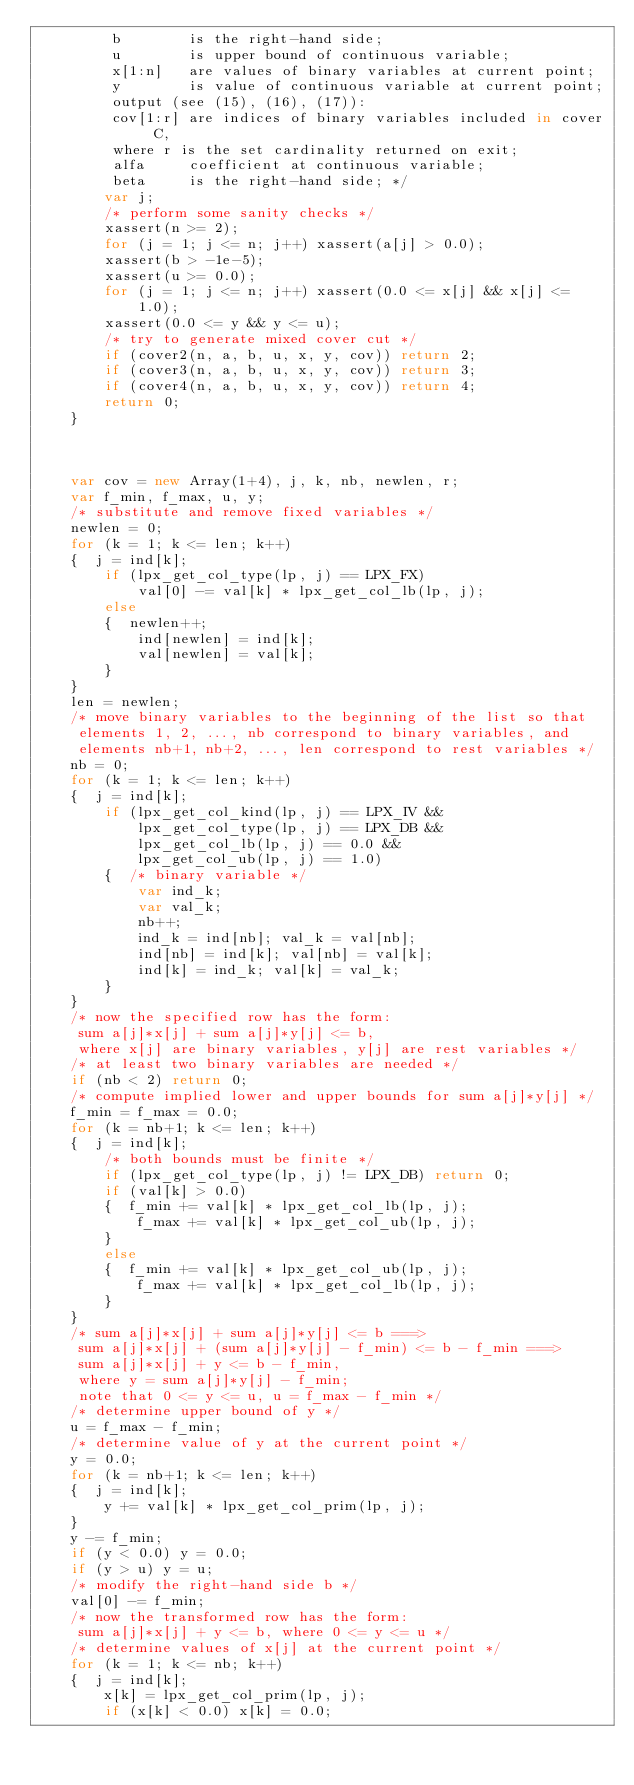Convert code to text. <code><loc_0><loc_0><loc_500><loc_500><_JavaScript_>         b        is the right-hand side;
         u        is upper bound of continuous variable;
         x[1:n]   are values of binary variables at current point;
         y        is value of continuous variable at current point;
         output (see (15), (16), (17)):
         cov[1:r] are indices of binary variables included in cover C,
         where r is the set cardinality returned on exit;
         alfa     coefficient at continuous variable;
         beta     is the right-hand side; */
        var j;
        /* perform some sanity checks */
        xassert(n >= 2);
        for (j = 1; j <= n; j++) xassert(a[j] > 0.0);
        xassert(b > -1e-5);
        xassert(u >= 0.0);
        for (j = 1; j <= n; j++) xassert(0.0 <= x[j] && x[j] <= 1.0);
        xassert(0.0 <= y && y <= u);
        /* try to generate mixed cover cut */
        if (cover2(n, a, b, u, x, y, cov)) return 2;
        if (cover3(n, a, b, u, x, y, cov)) return 3;
        if (cover4(n, a, b, u, x, y, cov)) return 4;
        return 0;
    }



    var cov = new Array(1+4), j, k, nb, newlen, r;
    var f_min, f_max, u, y;
    /* substitute and remove fixed variables */
    newlen = 0;
    for (k = 1; k <= len; k++)
    {  j = ind[k];
        if (lpx_get_col_type(lp, j) == LPX_FX)
            val[0] -= val[k] * lpx_get_col_lb(lp, j);
        else
        {  newlen++;
            ind[newlen] = ind[k];
            val[newlen] = val[k];
        }
    }
    len = newlen;
    /* move binary variables to the beginning of the list so that
     elements 1, 2, ..., nb correspond to binary variables, and
     elements nb+1, nb+2, ..., len correspond to rest variables */
    nb = 0;
    for (k = 1; k <= len; k++)
    {  j = ind[k];
        if (lpx_get_col_kind(lp, j) == LPX_IV &&
            lpx_get_col_type(lp, j) == LPX_DB &&
            lpx_get_col_lb(lp, j) == 0.0 &&
            lpx_get_col_ub(lp, j) == 1.0)
        {  /* binary variable */
            var ind_k;
            var val_k;
            nb++;
            ind_k = ind[nb]; val_k = val[nb];
            ind[nb] = ind[k]; val[nb] = val[k];
            ind[k] = ind_k; val[k] = val_k;
        }
    }
    /* now the specified row has the form:
     sum a[j]*x[j] + sum a[j]*y[j] <= b,
     where x[j] are binary variables, y[j] are rest variables */
    /* at least two binary variables are needed */
    if (nb < 2) return 0;
    /* compute implied lower and upper bounds for sum a[j]*y[j] */
    f_min = f_max = 0.0;
    for (k = nb+1; k <= len; k++)
    {  j = ind[k];
        /* both bounds must be finite */
        if (lpx_get_col_type(lp, j) != LPX_DB) return 0;
        if (val[k] > 0.0)
        {  f_min += val[k] * lpx_get_col_lb(lp, j);
            f_max += val[k] * lpx_get_col_ub(lp, j);
        }
        else
        {  f_min += val[k] * lpx_get_col_ub(lp, j);
            f_max += val[k] * lpx_get_col_lb(lp, j);
        }
    }
    /* sum a[j]*x[j] + sum a[j]*y[j] <= b ===>
     sum a[j]*x[j] + (sum a[j]*y[j] - f_min) <= b - f_min ===>
     sum a[j]*x[j] + y <= b - f_min,
     where y = sum a[j]*y[j] - f_min;
     note that 0 <= y <= u, u = f_max - f_min */
    /* determine upper bound of y */
    u = f_max - f_min;
    /* determine value of y at the current point */
    y = 0.0;
    for (k = nb+1; k <= len; k++)
    {  j = ind[k];
        y += val[k] * lpx_get_col_prim(lp, j);
    }
    y -= f_min;
    if (y < 0.0) y = 0.0;
    if (y > u) y = u;
    /* modify the right-hand side b */
    val[0] -= f_min;
    /* now the transformed row has the form:
     sum a[j]*x[j] + y <= b, where 0 <= y <= u */
    /* determine values of x[j] at the current point */
    for (k = 1; k <= nb; k++)
    {  j = ind[k];
        x[k] = lpx_get_col_prim(lp, j);
        if (x[k] < 0.0) x[k] = 0.0;</code> 